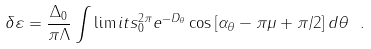Convert formula to latex. <formula><loc_0><loc_0><loc_500><loc_500>\delta \varepsilon = \frac { \Delta _ { 0 } } { \pi \Lambda } \int \lim i t s _ { 0 } ^ { 2 \pi } e ^ { - D _ { \theta } } \cos \left [ \alpha _ { \theta } - \pi \mu + \pi / 2 \right ] d \theta \ .</formula> 